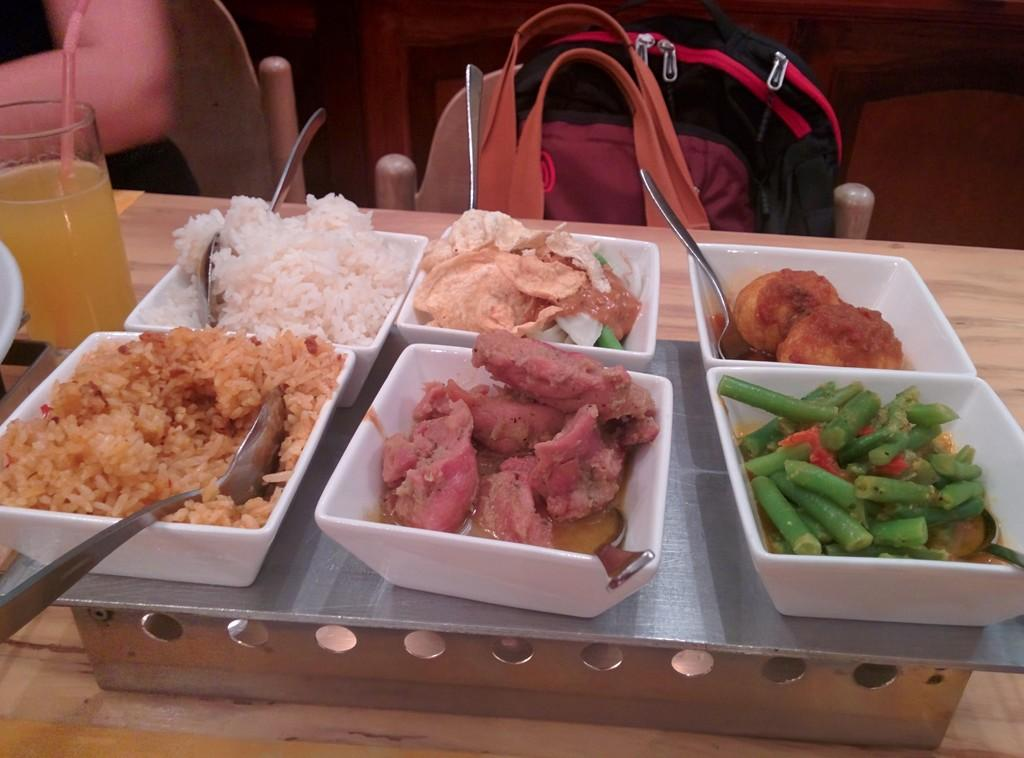What can be seen on the table in the image? There are different dishes and a glass on the table. What is located on the chair in the image? There is a bag on a chair. Where is the person sitting in the image? The person is sitting on a chair at the left side of the image. What type of notebook is the writer using in the image? There is no writer or notebook present in the image. What is on the top of the person's head in the image? There is no indication of anything on the person's head in the image. 